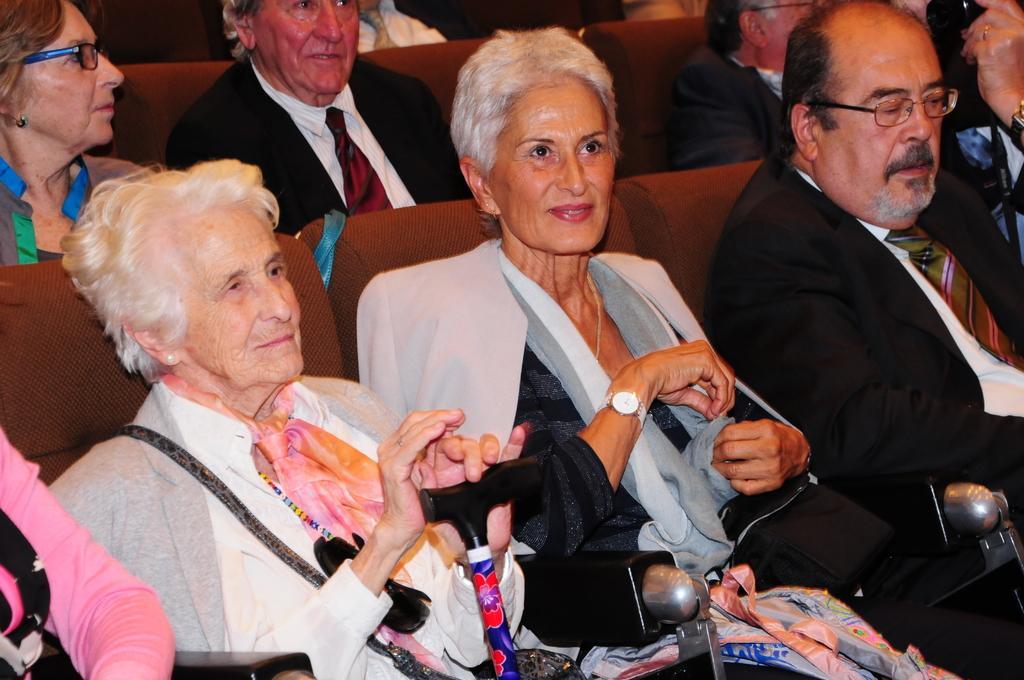Please provide a concise description of this image. In this image we can see two ladies sitting. The lady sitting on the left is holding a walking stick and we can see a bag. There is a man sitting next to them. He is wearing glasses. In the background there are people sitting and there are seats. 